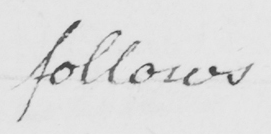Please transcribe the handwritten text in this image. follows 